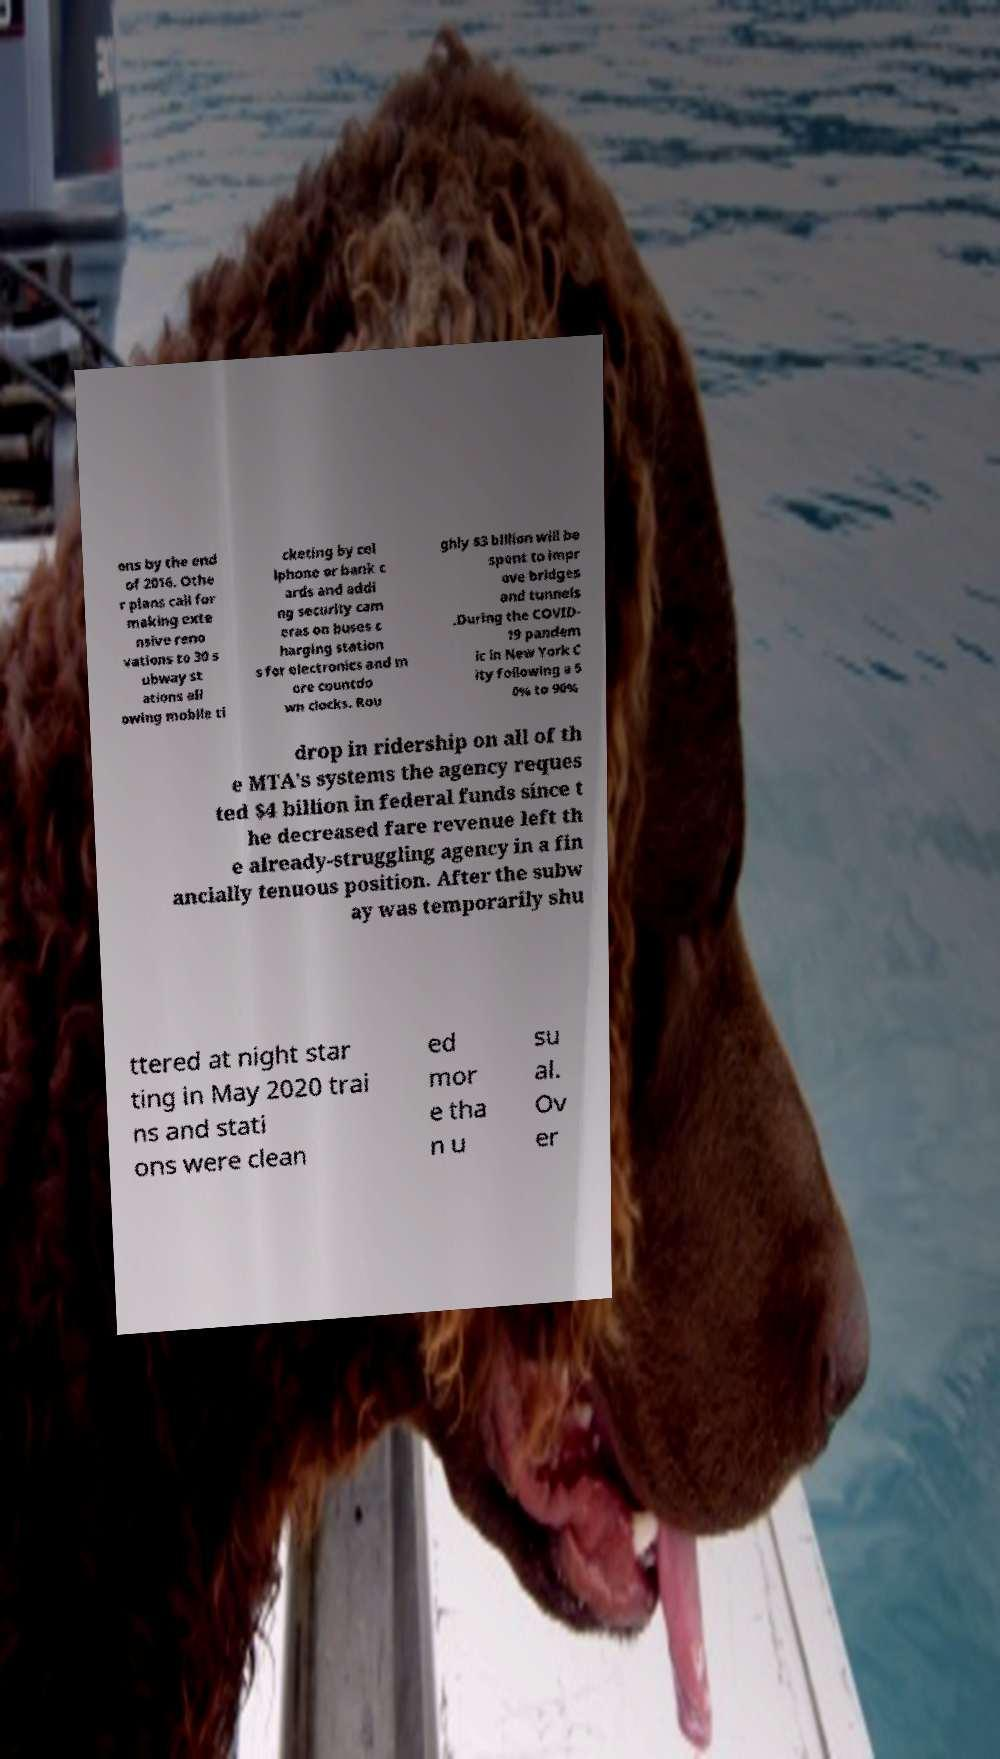Can you accurately transcribe the text from the provided image for me? ons by the end of 2016. Othe r plans call for making exte nsive reno vations to 30 s ubway st ations all owing mobile ti cketing by cel lphone or bank c ards and addi ng security cam eras on buses c harging station s for electronics and m ore countdo wn clocks. Rou ghly $3 billion will be spent to impr ove bridges and tunnels .During the COVID- 19 pandem ic in New York C ity following a 5 0% to 90% drop in ridership on all of th e MTA's systems the agency reques ted $4 billion in federal funds since t he decreased fare revenue left th e already-struggling agency in a fin ancially tenuous position. After the subw ay was temporarily shu ttered at night star ting in May 2020 trai ns and stati ons were clean ed mor e tha n u su al. Ov er 